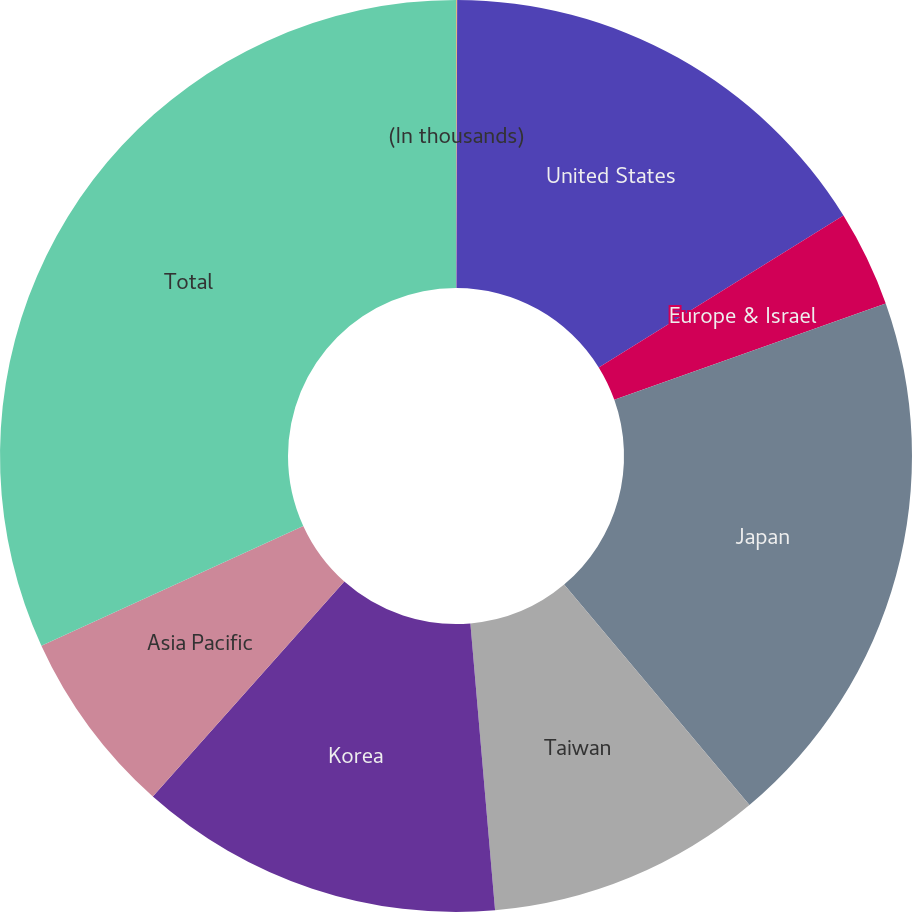Convert chart to OTSL. <chart><loc_0><loc_0><loc_500><loc_500><pie_chart><fcel>(In thousands)<fcel>United States<fcel>Europe & Israel<fcel>Japan<fcel>Taiwan<fcel>Korea<fcel>Asia Pacific<fcel>Total<nl><fcel>0.04%<fcel>16.12%<fcel>3.41%<fcel>19.3%<fcel>9.76%<fcel>12.94%<fcel>6.59%<fcel>31.83%<nl></chart> 